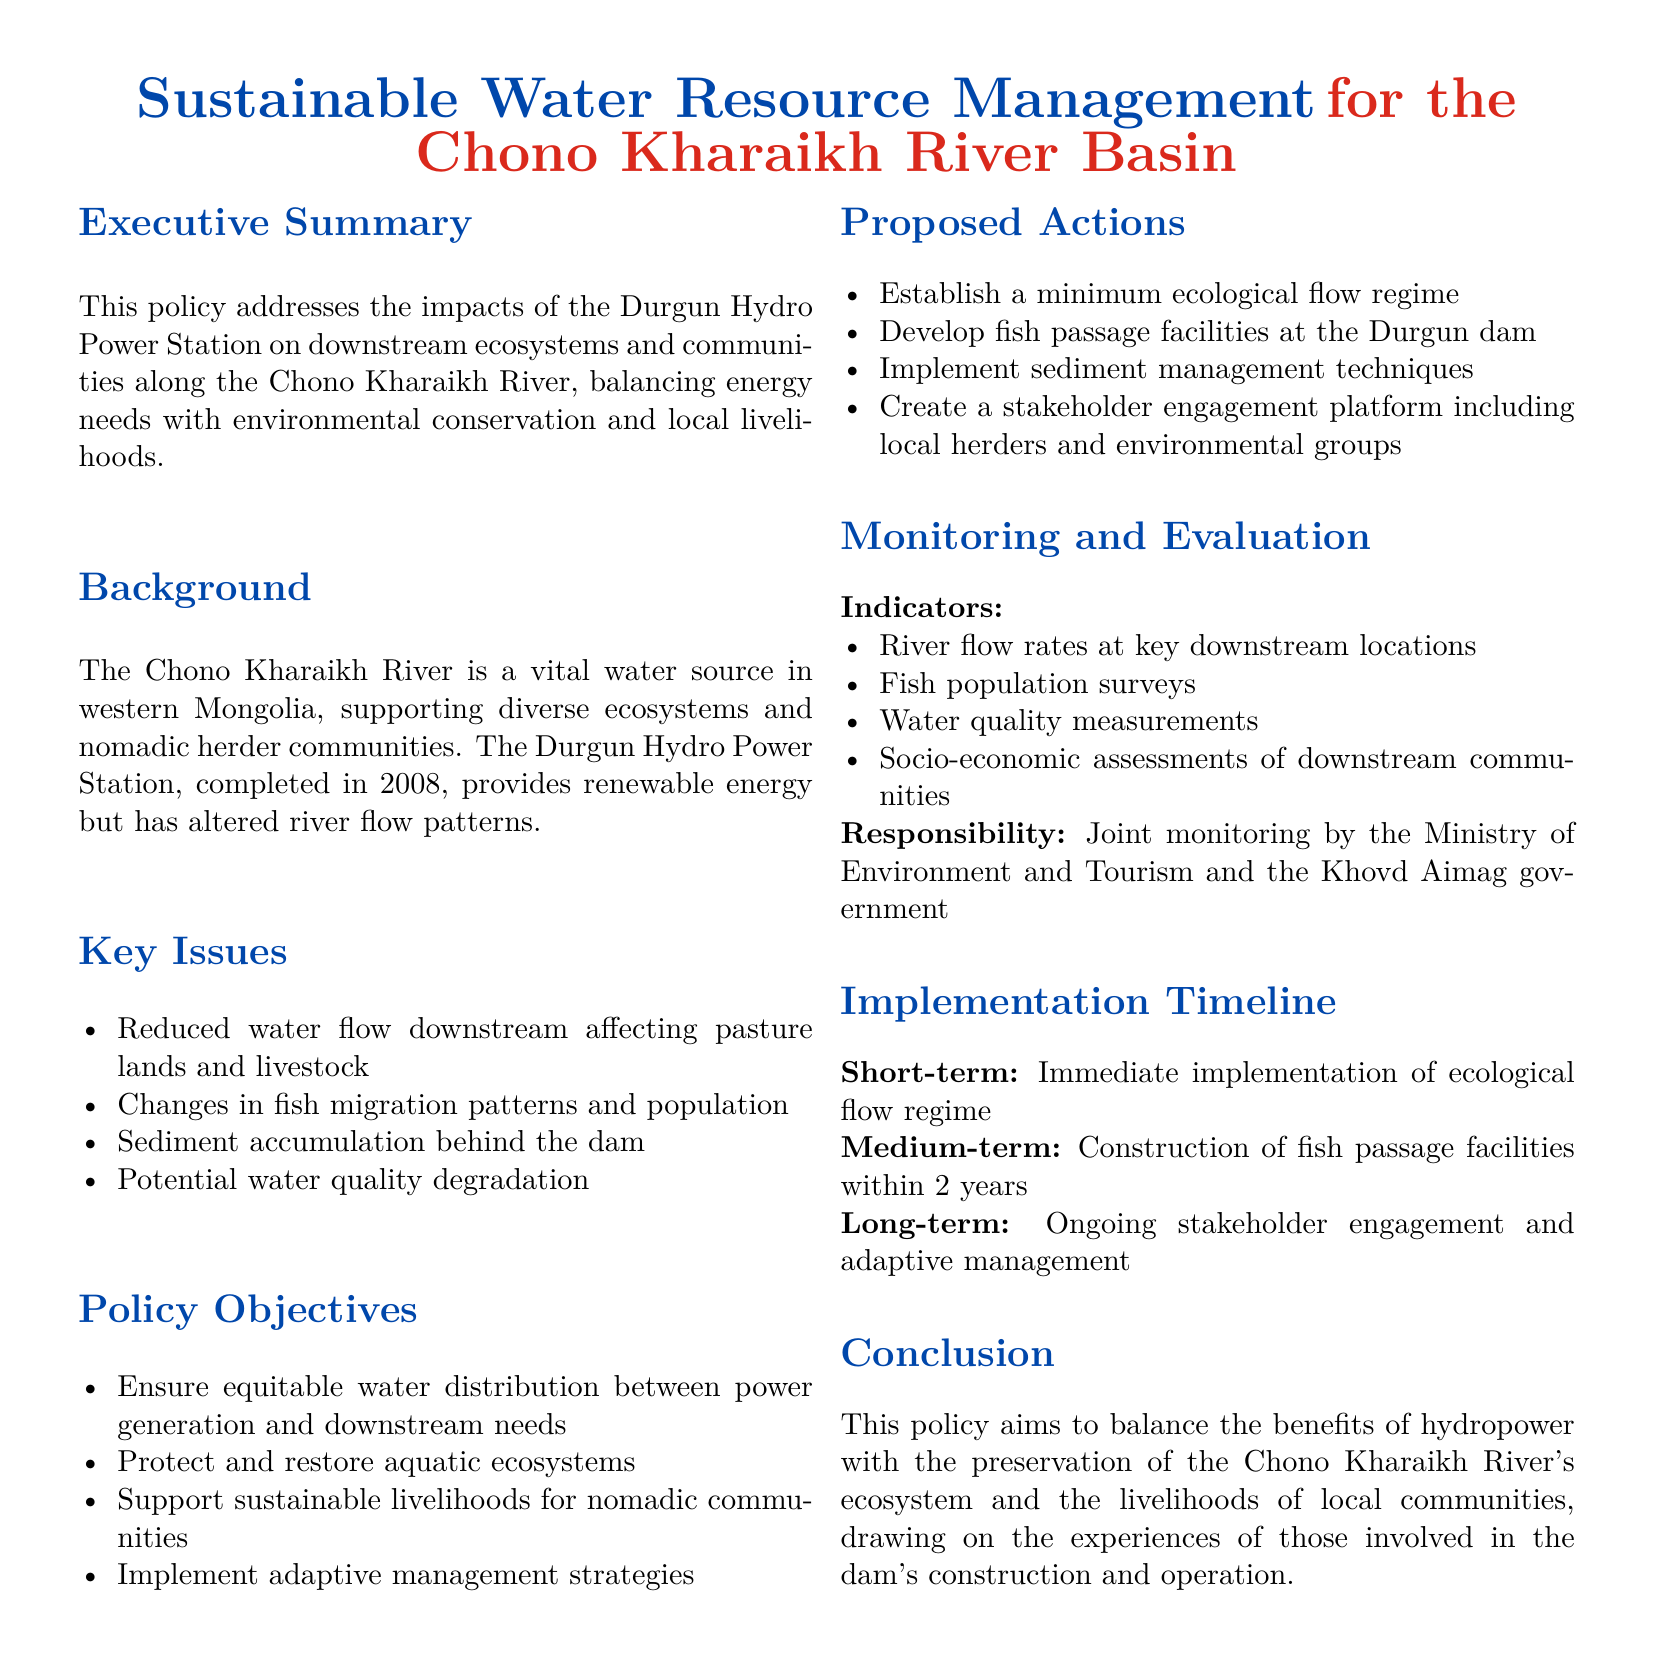what is the name of the river basin? The document specifically mentions the Chono Kharaikh River basin.
Answer: Chono Kharaikh River basin when was the Durgun Hydro Power Station completed? The completion date of the Durgun Hydro Power Station is stated in the document.
Answer: 2008 what are the proposed actions for sediment management? The document lists specific actions related to managing sediment behind the dam.
Answer: Implement sediment management techniques how many key issues are identified in the document? The document lists several key issues related to water resource management.
Answer: Four what is one objective of the policy mentioned? The document outlines several policy objectives meant to address local and ecological concerns.
Answer: Ensure equitable water distribution which organizations are responsible for monitoring and evaluation? The document specifies which entities will be jointly responsible for monitoring.
Answer: Ministry of Environment and Tourism and the Khovd Aimag government what is the short-term implementation goal? The document outlines specific timelines for the implementation of policy actions.
Answer: Immediate implementation of ecological flow regime how will local herders be involved in the policy? The document mentions the creation of a specific platform for engagement with local stakeholders.
Answer: Stakeholder engagement platform what type of surveys will be conducted to assess fish populations? The document refers to a specific type of assessment tool to monitor fish populations in the river.
Answer: Fish population surveys 